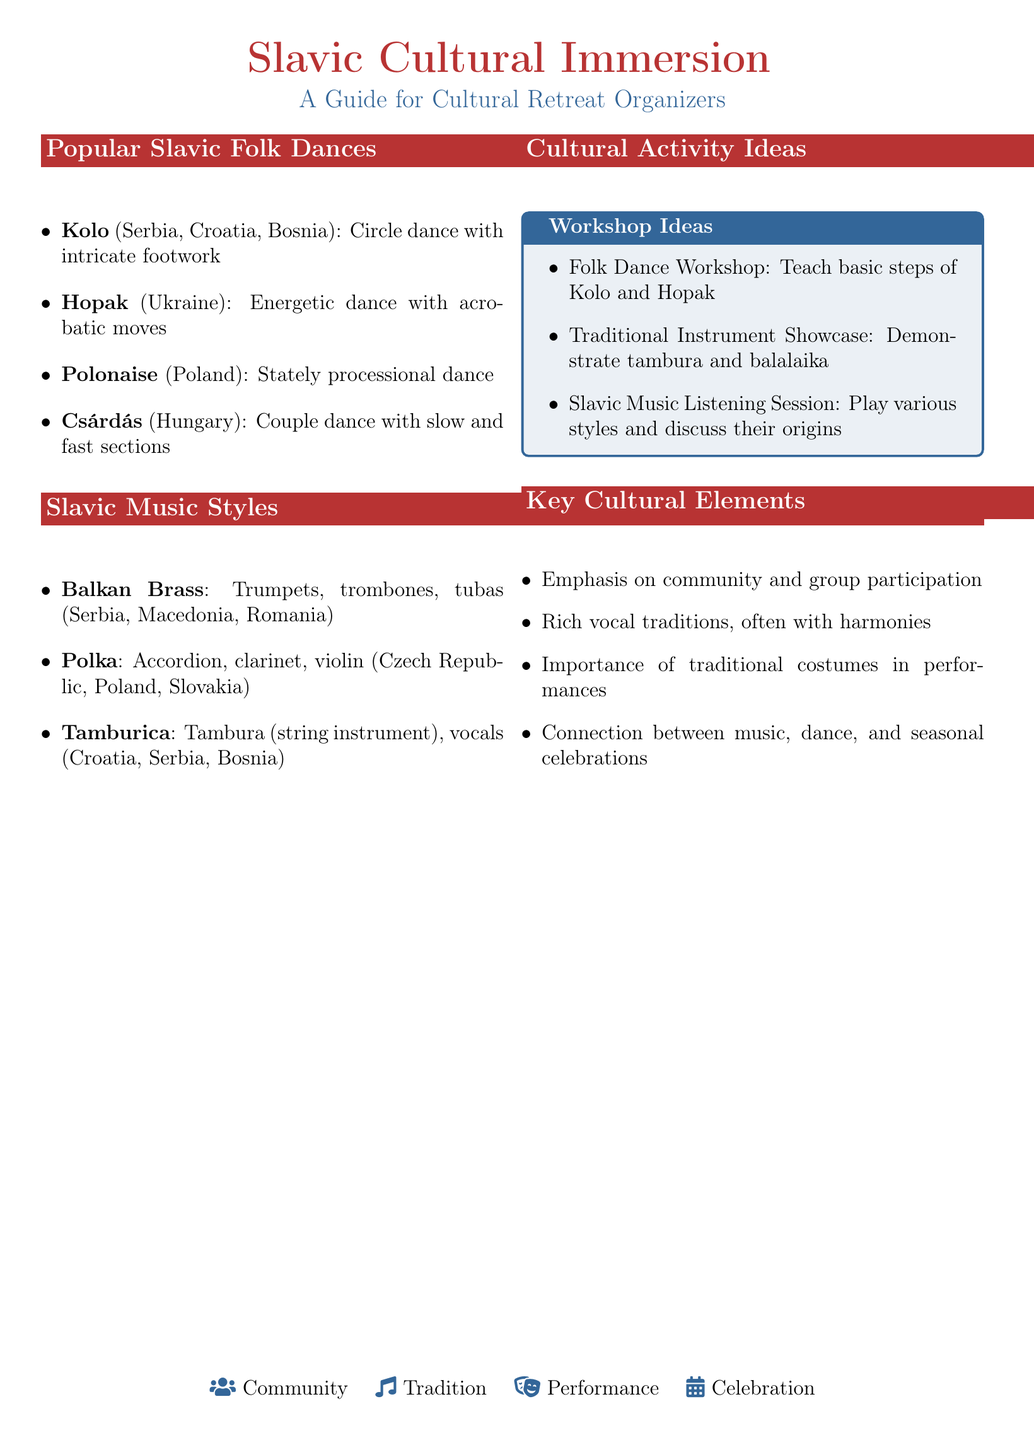What is the origin of Kolo? Kolo is noted to originate from Serbia, Croatia, and Bosnia.
Answer: Serbia, Croatia, Bosnia Which dance is known for its acrobatic moves? The Hopak is highlighted as an energetic dance featuring acrobatic moves.
Answer: Hopak What instruments are used in Balkan Brass music? The document specifies that Balkan Brass includes trumpets, trombones, and tubas.
Answer: Trumpets, trombones, tubas What is one idea for a cultural activity? The document lists various activities, one of which is a Folk Dance Workshop.
Answer: Folk Dance Workshop What is a key cultural element related to performances? It mentions the importance of traditional costumes in performances as a key cultural element.
Answer: Traditional costumes Which Slavic music style is popular in the Czech Republic? The document states that Polka is popular in the Czech Republic.
Answer: Polka What type of dance is Csárdás considered? Csárdás is categorized as a couple dance with slow and fast sections in the document.
Answer: Couple dance How many folk dances are listed in the document? The document provides a total of four folk dances under the Slavic Folk Dances section.
Answer: Four What community aspect is emphasized in the cultural elements? The document notes an emphasis on community and group participation as a key cultural element.
Answer: Community participation 